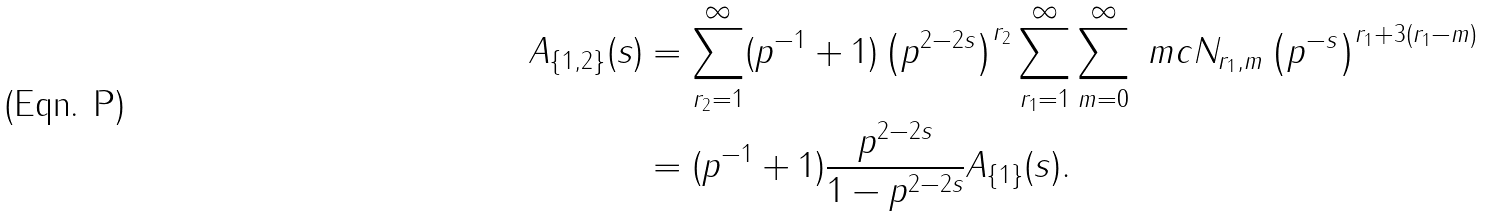Convert formula to latex. <formula><loc_0><loc_0><loc_500><loc_500>A _ { \{ 1 , 2 \} } ( s ) & = \sum _ { r _ { 2 } = 1 } ^ { \infty } ( p ^ { - 1 } + 1 ) \left ( p ^ { 2 - 2 s } \right ) ^ { r _ { 2 } } \sum _ { r _ { 1 } = 1 } ^ { \infty } \sum _ { m = 0 } ^ { \infty } \ m c N _ { r _ { 1 } , m } \left ( p ^ { - s } \right ) ^ { r _ { 1 } + 3 ( r _ { 1 } - m ) } \\ & = ( p ^ { - 1 } + 1 ) \frac { p ^ { 2 - 2 s } } { 1 - p ^ { 2 - 2 s } } A _ { \{ 1 \} } ( s ) .</formula> 